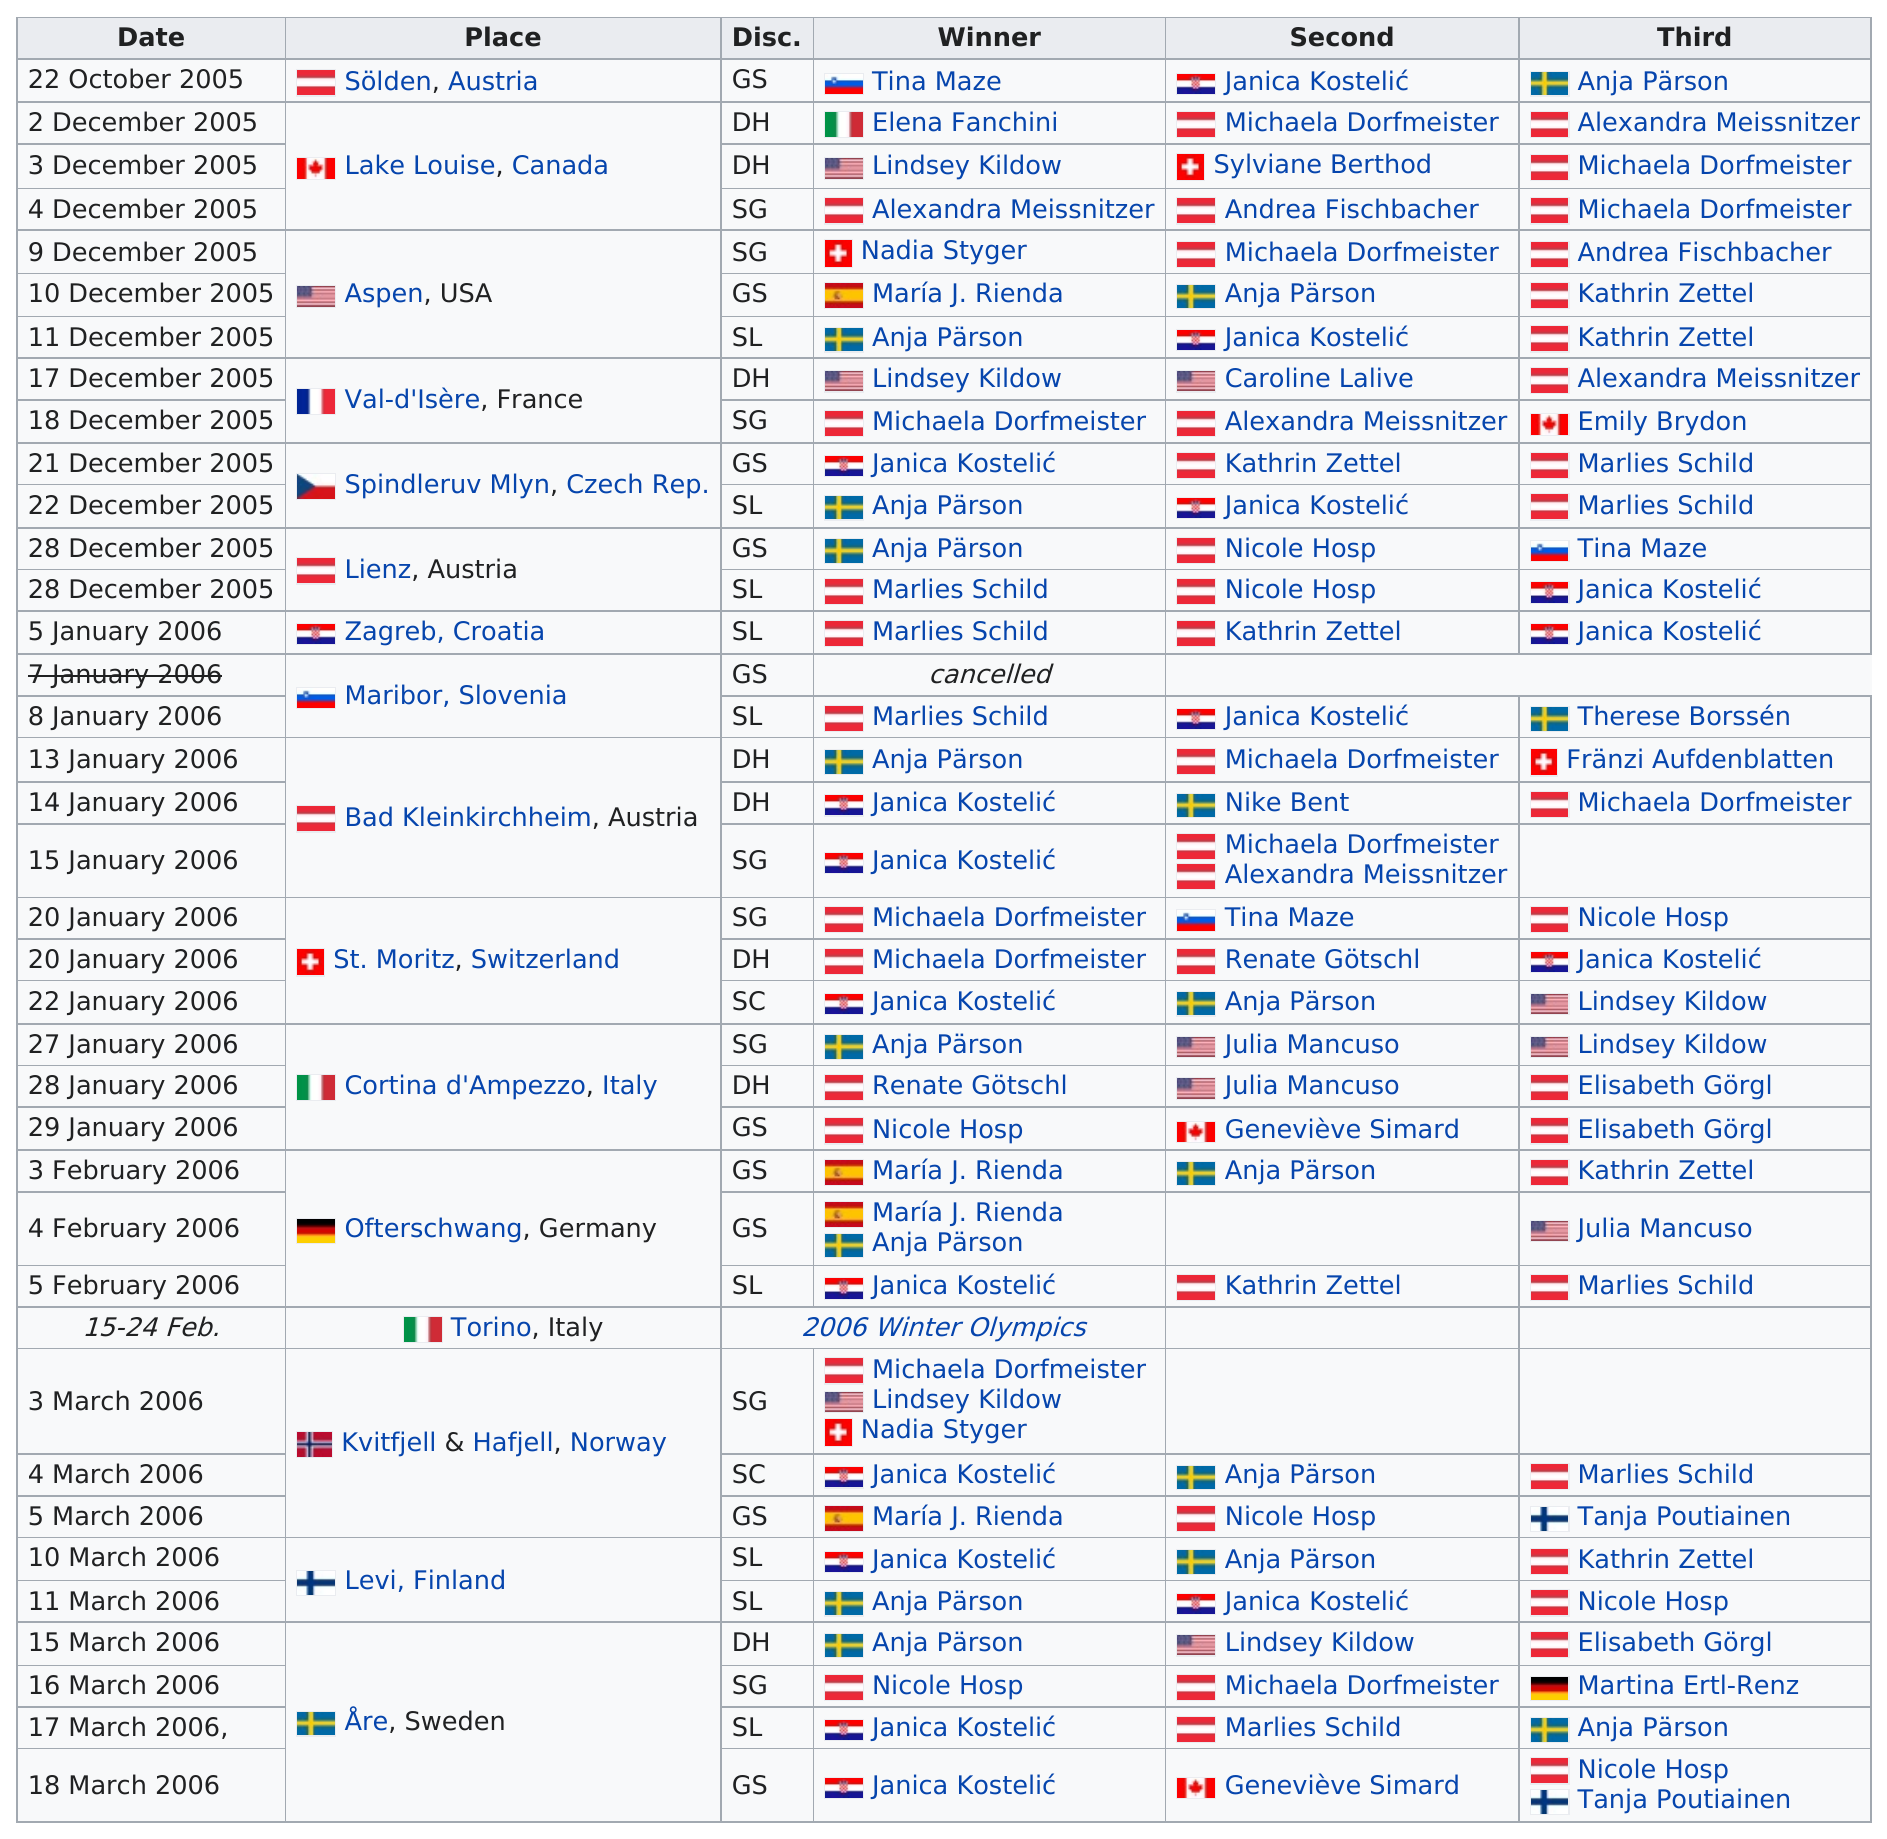Give some essential details in this illustration. Six women achieved consecutive third place wins. Nadia Styger was the top competitor at the December 9, 2005 games in Aspen. On March 15, 2006, Anja Pärson earned the first place in the 2006 Alpine Skiing World Cup. Janica Kostelić's competitor has had the most 1st place finishes. It is clear that Spain won the first place, as stated in the sentence "did Sweden or Spain win first?" implying that the answer is Spain. 